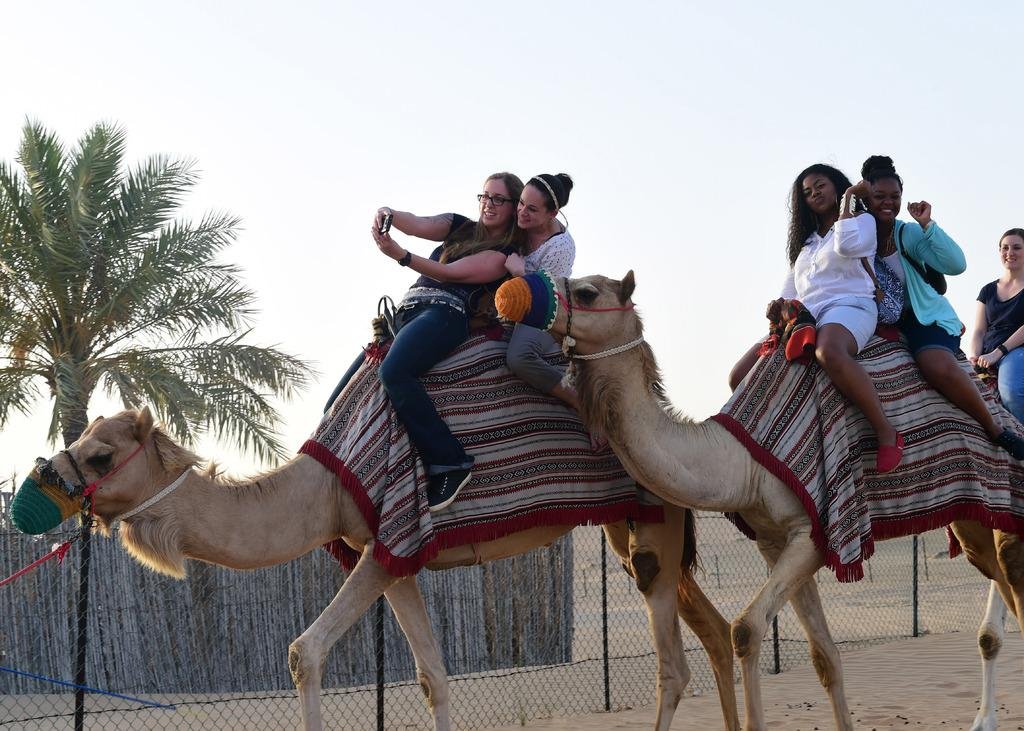Who is present in the image? There are women in the image. What are the women doing in the image? The women are sitting on a camel. What can be seen in the background of the image? There is a mesh, a wooden fence, a tree, and the sky visible in the image. What company is the camel working for in the image? There is no indication in the image that the camel is working for a company. 